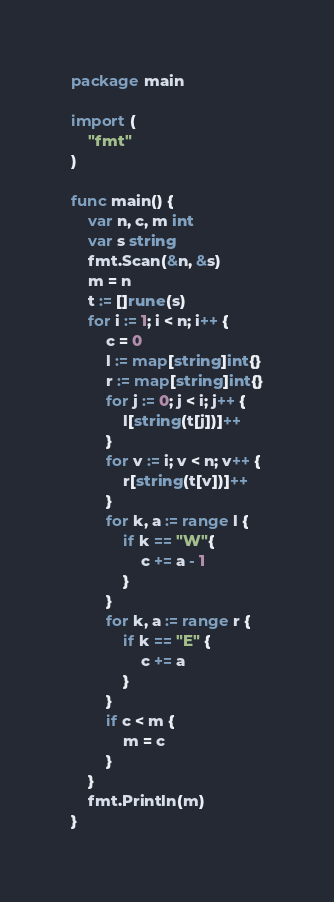<code> <loc_0><loc_0><loc_500><loc_500><_Go_>package main
 
import (
	"fmt"
)
 
func main() {
	var n, c, m int
	var s string
	fmt.Scan(&n, &s)
	m = n
	t := []rune(s)
	for i := 1; i < n; i++ {
		c = 0
		l := map[string]int{}
		r := map[string]int{}
		for j := 0; j < i; j++ {
			l[string(t[j])]++
		}
		for v := i; v < n; v++ {
			r[string(t[v])]++
		}
		for k, a := range l {
			if k == "W"{
				c += a - 1
			}
		}
		for k, a := range r {
			if k == "E" {
				c += a
			}
		}
		if c < m {
			m = c
		}
	}
	fmt.Println(m)
}</code> 